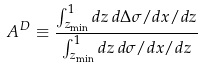Convert formula to latex. <formula><loc_0><loc_0><loc_500><loc_500>A ^ { D } \equiv \frac { \int _ { z _ { \min } } ^ { 1 } d z \, d \Delta \sigma / d x / d z } { \int _ { z _ { \min } } ^ { 1 } d z \, d \sigma / d x / d z }</formula> 